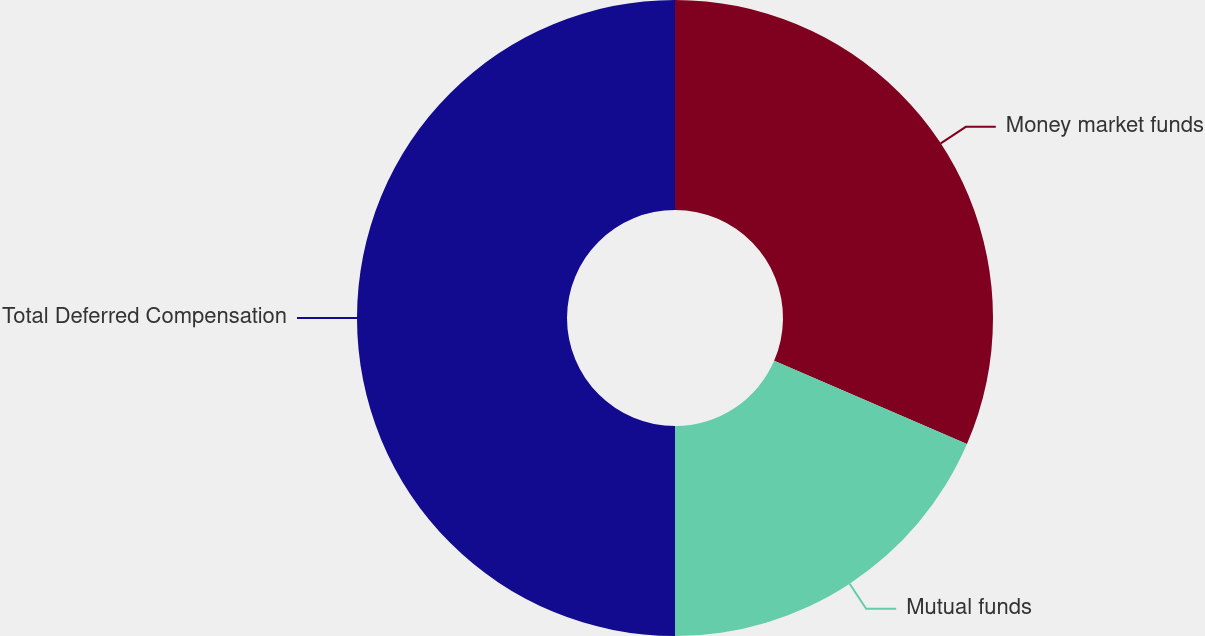Convert chart to OTSL. <chart><loc_0><loc_0><loc_500><loc_500><pie_chart><fcel>Money market funds<fcel>Mutual funds<fcel>Total Deferred Compensation<nl><fcel>31.49%<fcel>18.51%<fcel>50.0%<nl></chart> 